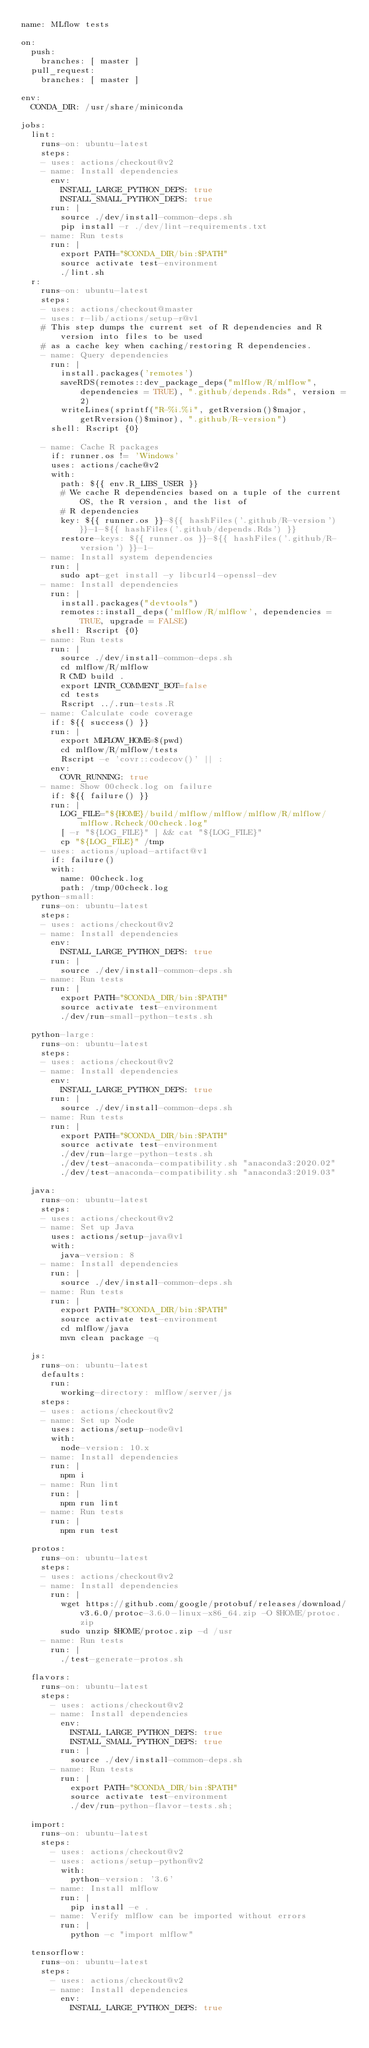Convert code to text. <code><loc_0><loc_0><loc_500><loc_500><_YAML_>name: MLflow tests

on:
  push:
    branches: [ master ]
  pull_request:
    branches: [ master ]

env:
  CONDA_DIR: /usr/share/miniconda

jobs:
  lint:
    runs-on: ubuntu-latest
    steps:
    - uses: actions/checkout@v2
    - name: Install dependencies
      env:
        INSTALL_LARGE_PYTHON_DEPS: true
        INSTALL_SMALL_PYTHON_DEPS: true
      run: |
        source ./dev/install-common-deps.sh
        pip install -r ./dev/lint-requirements.txt
    - name: Run tests
      run: |
        export PATH="$CONDA_DIR/bin:$PATH"
        source activate test-environment
        ./lint.sh
  r:
    runs-on: ubuntu-latest
    steps:
    - uses: actions/checkout@master
    - uses: r-lib/actions/setup-r@v1
    # This step dumps the current set of R dependencies and R version into files to be used
    # as a cache key when caching/restoring R dependencies.
    - name: Query dependencies
      run: |
        install.packages('remotes')
        saveRDS(remotes::dev_package_deps("mlflow/R/mlflow", dependencies = TRUE), ".github/depends.Rds", version = 2)
        writeLines(sprintf("R-%i.%i", getRversion()$major, getRversion()$minor), ".github/R-version")
      shell: Rscript {0}

    - name: Cache R packages
      if: runner.os != 'Windows'
      uses: actions/cache@v2
      with:
        path: ${{ env.R_LIBS_USER }}
        # We cache R dependencies based on a tuple of the current OS, the R version, and the list of
        # R dependencies
        key: ${{ runner.os }}-${{ hashFiles('.github/R-version') }}-1-${{ hashFiles('.github/depends.Rds') }}
        restore-keys: ${{ runner.os }}-${{ hashFiles('.github/R-version') }}-1-
    - name: Install system dependencies
      run: |
        sudo apt-get install -y libcurl4-openssl-dev
    - name: Install dependencies
      run: |
        install.packages("devtools")
        remotes::install_deps('mlflow/R/mlflow', dependencies = TRUE, upgrade = FALSE)
      shell: Rscript {0}
    - name: Run tests
      run: |
        source ./dev/install-common-deps.sh
        cd mlflow/R/mlflow
        R CMD build .
        export LINTR_COMMENT_BOT=false
        cd tests
        Rscript ../.run-tests.R
    - name: Calculate code coverage
      if: ${{ success() }}
      run: |
        export MLFLOW_HOME=$(pwd)
        cd mlflow/R/mlflow/tests
        Rscript -e 'covr::codecov()' || :
      env:
        COVR_RUNNING: true
    - name: Show 00check.log on failure
      if: ${{ failure() }}
      run: |
        LOG_FILE="${HOME}/build/mlflow/mlflow/mlflow/R/mlflow/mlflow.Rcheck/00check.log"
        [ -r "${LOG_FILE}" ] && cat "${LOG_FILE}"
        cp "${LOG_FILE}" /tmp
    - uses: actions/upload-artifact@v1
      if: failure()
      with:
        name: 00check.log
        path: /tmp/00check.log
  python-small:
    runs-on: ubuntu-latest
    steps:
    - uses: actions/checkout@v2
    - name: Install dependencies
      env:
        INSTALL_LARGE_PYTHON_DEPS: true
      run: |
        source ./dev/install-common-deps.sh
    - name: Run tests
      run: |
        export PATH="$CONDA_DIR/bin:$PATH"
        source activate test-environment
        ./dev/run-small-python-tests.sh

  python-large:
    runs-on: ubuntu-latest
    steps:
    - uses: actions/checkout@v2
    - name: Install dependencies
      env:
        INSTALL_LARGE_PYTHON_DEPS: true
      run: |
        source ./dev/install-common-deps.sh
    - name: Run tests
      run: |
        export PATH="$CONDA_DIR/bin:$PATH"
        source activate test-environment
        ./dev/run-large-python-tests.sh
        ./dev/test-anaconda-compatibility.sh "anaconda3:2020.02"
        ./dev/test-anaconda-compatibility.sh "anaconda3:2019.03"

  java:
    runs-on: ubuntu-latest
    steps:
    - uses: actions/checkout@v2
    - name: Set up Java
      uses: actions/setup-java@v1
      with:
        java-version: 8
    - name: Install dependencies
      run: |
        source ./dev/install-common-deps.sh
    - name: Run tests
      run: |
        export PATH="$CONDA_DIR/bin:$PATH"
        source activate test-environment
        cd mlflow/java
        mvn clean package -q

  js:
    runs-on: ubuntu-latest
    defaults:
      run:
        working-directory: mlflow/server/js
    steps:
    - uses: actions/checkout@v2
    - name: Set up Node
      uses: actions/setup-node@v1
      with:
        node-version: 10.x
    - name: Install dependencies
      run: |
        npm i
    - name: Run lint
      run: |
        npm run lint
    - name: Run tests
      run: |
        npm run test

  protos:
    runs-on: ubuntu-latest
    steps:
    - uses: actions/checkout@v2
    - name: Install dependencies
      run: |
        wget https://github.com/google/protobuf/releases/download/v3.6.0/protoc-3.6.0-linux-x86_64.zip -O $HOME/protoc.zip
        sudo unzip $HOME/protoc.zip -d /usr
    - name: Run tests
      run: |
        ./test-generate-protos.sh

  flavors:
    runs-on: ubuntu-latest
    steps:
      - uses: actions/checkout@v2
      - name: Install dependencies
        env:
          INSTALL_LARGE_PYTHON_DEPS: true
          INSTALL_SMALL_PYTHON_DEPS: true
        run: |
          source ./dev/install-common-deps.sh
      - name: Run tests
        run: |
          export PATH="$CONDA_DIR/bin:$PATH"
          source activate test-environment
          ./dev/run-python-flavor-tests.sh;

  import:
    runs-on: ubuntu-latest
    steps:
      - uses: actions/checkout@v2
      - uses: actions/setup-python@v2
        with:
          python-version: '3.6'
      - name: Install mlflow
        run: |
          pip install -e .
      - name: Verify mlflow can be imported without errors
        run: |
          python -c "import mlflow"

  tensorflow:
    runs-on: ubuntu-latest
    steps:
      - uses: actions/checkout@v2
      - name: Install dependencies
        env:
          INSTALL_LARGE_PYTHON_DEPS: true</code> 